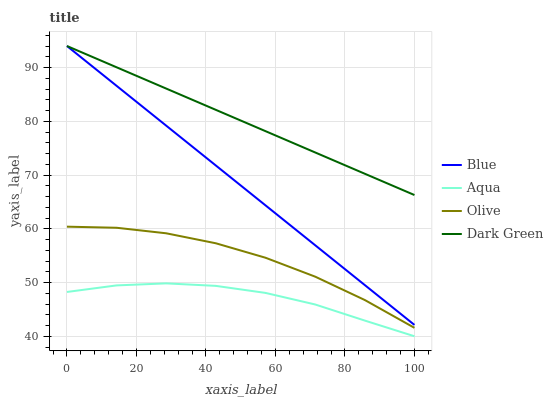Does Aqua have the minimum area under the curve?
Answer yes or no. Yes. Does Dark Green have the maximum area under the curve?
Answer yes or no. Yes. Does Olive have the minimum area under the curve?
Answer yes or no. No. Does Olive have the maximum area under the curve?
Answer yes or no. No. Is Blue the smoothest?
Answer yes or no. Yes. Is Olive the roughest?
Answer yes or no. Yes. Is Aqua the smoothest?
Answer yes or no. No. Is Aqua the roughest?
Answer yes or no. No. Does Aqua have the lowest value?
Answer yes or no. Yes. Does Olive have the lowest value?
Answer yes or no. No. Does Dark Green have the highest value?
Answer yes or no. Yes. Does Olive have the highest value?
Answer yes or no. No. Is Olive less than Dark Green?
Answer yes or no. Yes. Is Blue greater than Olive?
Answer yes or no. Yes. Does Dark Green intersect Blue?
Answer yes or no. Yes. Is Dark Green less than Blue?
Answer yes or no. No. Is Dark Green greater than Blue?
Answer yes or no. No. Does Olive intersect Dark Green?
Answer yes or no. No. 